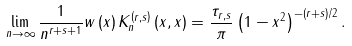Convert formula to latex. <formula><loc_0><loc_0><loc_500><loc_500>\lim _ { n \rightarrow \infty } \frac { 1 } { n ^ { r + s + 1 } } w \left ( x \right ) K _ { n } ^ { \left ( r , s \right ) } \left ( x , x \right ) = \frac { \tau _ { r , s } } { \pi } \left ( 1 - x ^ { 2 } \right ) ^ { - \left ( r + s \right ) / 2 } .</formula> 